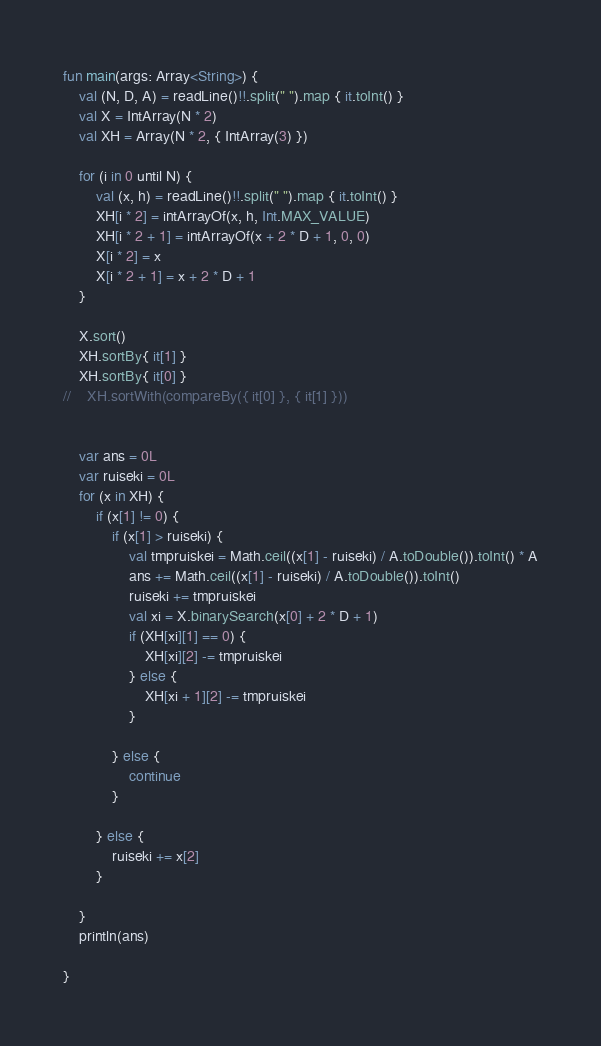Convert code to text. <code><loc_0><loc_0><loc_500><loc_500><_Kotlin_>fun main(args: Array<String>) {
    val (N, D, A) = readLine()!!.split(" ").map { it.toInt() }
    val X = IntArray(N * 2)
    val XH = Array(N * 2, { IntArray(3) })

    for (i in 0 until N) {
        val (x, h) = readLine()!!.split(" ").map { it.toInt() }
        XH[i * 2] = intArrayOf(x, h, Int.MAX_VALUE)
        XH[i * 2 + 1] = intArrayOf(x + 2 * D + 1, 0, 0)
        X[i * 2] = x
        X[i * 2 + 1] = x + 2 * D + 1
    }

    X.sort()
    XH.sortBy{ it[1] }
    XH.sortBy{ it[0] }
//    XH.sortWith(compareBy({ it[0] }, { it[1] }))


    var ans = 0L
    var ruiseki = 0L
    for (x in XH) {
        if (x[1] != 0) {
            if (x[1] > ruiseki) {
                val tmpruiskei = Math.ceil((x[1] - ruiseki) / A.toDouble()).toInt() * A
                ans += Math.ceil((x[1] - ruiseki) / A.toDouble()).toInt()
                ruiseki += tmpruiskei
                val xi = X.binarySearch(x[0] + 2 * D + 1)
                if (XH[xi][1] == 0) {
                    XH[xi][2] -= tmpruiskei
                } else {
                    XH[xi + 1][2] -= tmpruiskei
                }

            } else {
                continue
            }

        } else {
            ruiseki += x[2]
        }

    }
    println(ans)

}</code> 